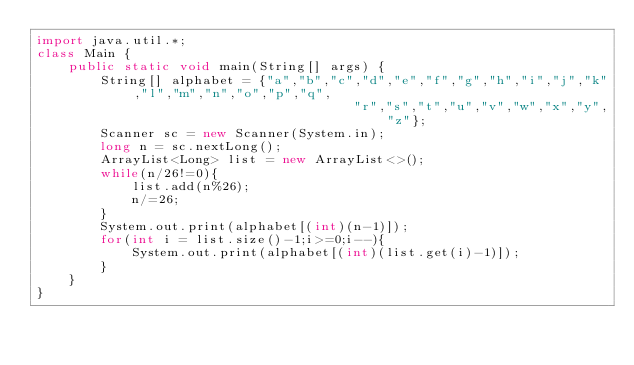Convert code to text. <code><loc_0><loc_0><loc_500><loc_500><_Java_>import java.util.*;
class Main {
	public static void main(String[] args) {
        String[] alphabet = {"a","b","c","d","e","f","g","h","i","j","k","l","m","n","o","p","q",
                                        "r","s","t","u","v","w","x","y","z"};
        Scanner sc = new Scanner(System.in);
        long n = sc.nextLong();
        ArrayList<Long> list = new ArrayList<>();
        while(n/26!=0){
            list.add(n%26);
            n/=26;
        }
        System.out.print(alphabet[(int)(n-1)]);
        for(int i = list.size()-1;i>=0;i--){
            System.out.print(alphabet[(int)(list.get(i)-1)]);
        }
    }
}
</code> 